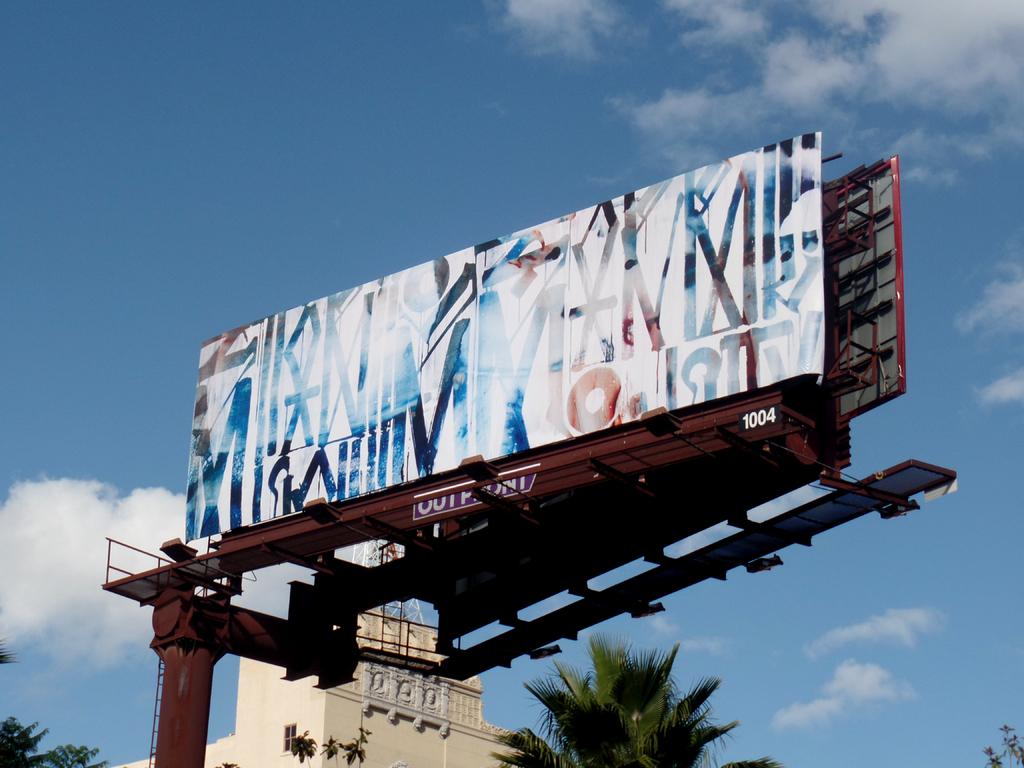What number is written in the lower right corner of the billboard frame?
Offer a very short reply. 1004. 